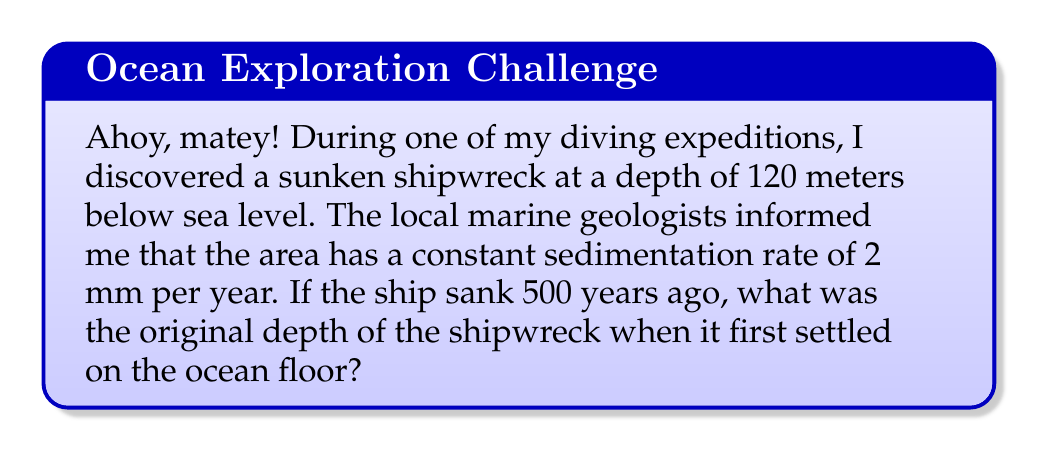Help me with this question. Let's approach this problem step by step:

1) First, we need to calculate how much sediment has accumulated over 500 years:
   
   Sedimentation rate = 2 mm/year
   Time elapsed = 500 years
   
   Total sediment accumulation = $2 \frac{\text{mm}}{\text{year}} \times 500 \text{ years} = 1000 \text{ mm} = 1 \text{ m}$

2) Now, we know that the current depth (120 m) is the sum of the original depth and the sediment accumulation:

   $$\text{Current Depth} = \text{Original Depth} + \text{Sediment Accumulation}$$

3) Let's express this mathematically:
   
   $$120 \text{ m} = x + 1 \text{ m}$$

   Where $x$ is the original depth we're trying to find.

4) To solve for $x$, we simply subtract 1 m from both sides:

   $$x = 120 \text{ m} - 1 \text{ m} = 119 \text{ m}$$

Therefore, the original depth of the shipwreck when it first settled on the ocean floor was 119 meters.
Answer: 119 m 